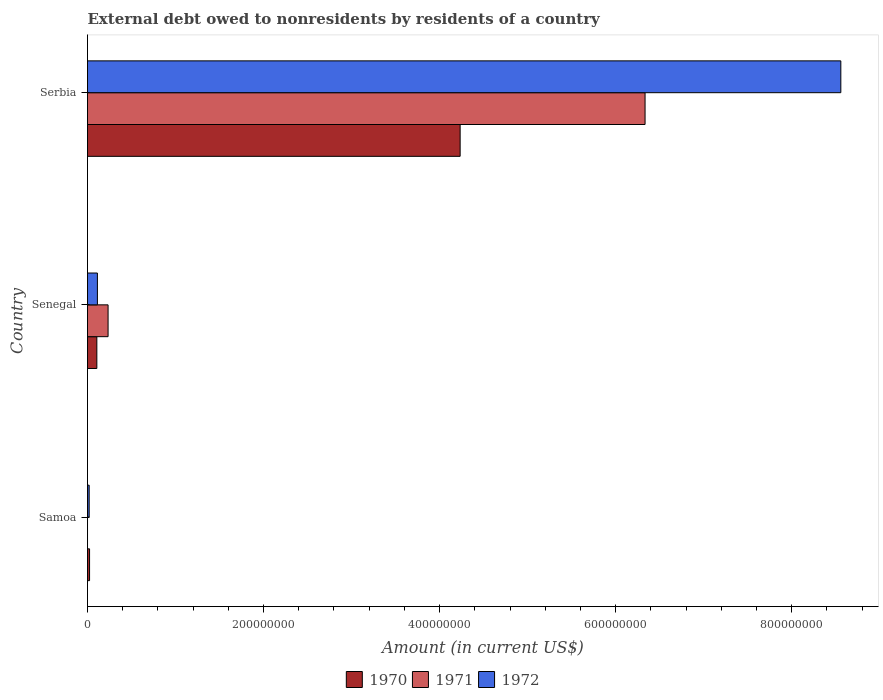How many different coloured bars are there?
Offer a terse response. 3. How many bars are there on the 2nd tick from the top?
Keep it short and to the point. 3. What is the label of the 2nd group of bars from the top?
Offer a very short reply. Senegal. What is the external debt owed by residents in 1972 in Senegal?
Your answer should be very brief. 1.12e+07. Across all countries, what is the maximum external debt owed by residents in 1970?
Provide a short and direct response. 4.23e+08. Across all countries, what is the minimum external debt owed by residents in 1972?
Your answer should be compact. 1.89e+06. In which country was the external debt owed by residents in 1970 maximum?
Your answer should be compact. Serbia. What is the total external debt owed by residents in 1972 in the graph?
Your response must be concise. 8.69e+08. What is the difference between the external debt owed by residents in 1972 in Samoa and that in Senegal?
Make the answer very short. -9.34e+06. What is the difference between the external debt owed by residents in 1970 in Serbia and the external debt owed by residents in 1971 in Senegal?
Your answer should be compact. 4.00e+08. What is the average external debt owed by residents in 1971 per country?
Give a very brief answer. 2.19e+08. What is the difference between the external debt owed by residents in 1970 and external debt owed by residents in 1972 in Serbia?
Provide a succinct answer. -4.32e+08. What is the ratio of the external debt owed by residents in 1970 in Samoa to that in Serbia?
Make the answer very short. 0.01. Is the external debt owed by residents in 1970 in Samoa less than that in Serbia?
Provide a succinct answer. Yes. Is the difference between the external debt owed by residents in 1970 in Samoa and Senegal greater than the difference between the external debt owed by residents in 1972 in Samoa and Senegal?
Offer a very short reply. Yes. What is the difference between the highest and the second highest external debt owed by residents in 1970?
Provide a succinct answer. 4.13e+08. What is the difference between the highest and the lowest external debt owed by residents in 1972?
Offer a terse response. 8.54e+08. What is the difference between two consecutive major ticks on the X-axis?
Your answer should be very brief. 2.00e+08. Are the values on the major ticks of X-axis written in scientific E-notation?
Make the answer very short. No. Does the graph contain grids?
Your answer should be compact. No. How many legend labels are there?
Offer a terse response. 3. What is the title of the graph?
Your answer should be very brief. External debt owed to nonresidents by residents of a country. What is the label or title of the Y-axis?
Ensure brevity in your answer.  Country. What is the Amount (in current US$) of 1970 in Samoa?
Offer a terse response. 2.32e+06. What is the Amount (in current US$) in 1972 in Samoa?
Provide a short and direct response. 1.89e+06. What is the Amount (in current US$) of 1970 in Senegal?
Provide a succinct answer. 1.06e+07. What is the Amount (in current US$) of 1971 in Senegal?
Ensure brevity in your answer.  2.34e+07. What is the Amount (in current US$) of 1972 in Senegal?
Your answer should be very brief. 1.12e+07. What is the Amount (in current US$) in 1970 in Serbia?
Your response must be concise. 4.23e+08. What is the Amount (in current US$) of 1971 in Serbia?
Make the answer very short. 6.33e+08. What is the Amount (in current US$) in 1972 in Serbia?
Your response must be concise. 8.56e+08. Across all countries, what is the maximum Amount (in current US$) in 1970?
Your answer should be very brief. 4.23e+08. Across all countries, what is the maximum Amount (in current US$) in 1971?
Give a very brief answer. 6.33e+08. Across all countries, what is the maximum Amount (in current US$) in 1972?
Your answer should be compact. 8.56e+08. Across all countries, what is the minimum Amount (in current US$) of 1970?
Your response must be concise. 2.32e+06. Across all countries, what is the minimum Amount (in current US$) of 1972?
Your answer should be compact. 1.89e+06. What is the total Amount (in current US$) of 1970 in the graph?
Provide a short and direct response. 4.36e+08. What is the total Amount (in current US$) of 1971 in the graph?
Keep it short and to the point. 6.57e+08. What is the total Amount (in current US$) in 1972 in the graph?
Offer a very short reply. 8.69e+08. What is the difference between the Amount (in current US$) of 1970 in Samoa and that in Senegal?
Offer a terse response. -8.28e+06. What is the difference between the Amount (in current US$) of 1972 in Samoa and that in Senegal?
Offer a terse response. -9.34e+06. What is the difference between the Amount (in current US$) in 1970 in Samoa and that in Serbia?
Provide a succinct answer. -4.21e+08. What is the difference between the Amount (in current US$) of 1972 in Samoa and that in Serbia?
Provide a succinct answer. -8.54e+08. What is the difference between the Amount (in current US$) in 1970 in Senegal and that in Serbia?
Give a very brief answer. -4.13e+08. What is the difference between the Amount (in current US$) of 1971 in Senegal and that in Serbia?
Keep it short and to the point. -6.10e+08. What is the difference between the Amount (in current US$) of 1972 in Senegal and that in Serbia?
Your response must be concise. -8.45e+08. What is the difference between the Amount (in current US$) of 1970 in Samoa and the Amount (in current US$) of 1971 in Senegal?
Offer a terse response. -2.10e+07. What is the difference between the Amount (in current US$) in 1970 in Samoa and the Amount (in current US$) in 1972 in Senegal?
Your answer should be very brief. -8.91e+06. What is the difference between the Amount (in current US$) in 1970 in Samoa and the Amount (in current US$) in 1971 in Serbia?
Your response must be concise. -6.31e+08. What is the difference between the Amount (in current US$) of 1970 in Samoa and the Amount (in current US$) of 1972 in Serbia?
Ensure brevity in your answer.  -8.54e+08. What is the difference between the Amount (in current US$) in 1970 in Senegal and the Amount (in current US$) in 1971 in Serbia?
Provide a succinct answer. -6.23e+08. What is the difference between the Amount (in current US$) in 1970 in Senegal and the Amount (in current US$) in 1972 in Serbia?
Give a very brief answer. -8.45e+08. What is the difference between the Amount (in current US$) in 1971 in Senegal and the Amount (in current US$) in 1972 in Serbia?
Offer a terse response. -8.32e+08. What is the average Amount (in current US$) of 1970 per country?
Provide a succinct answer. 1.45e+08. What is the average Amount (in current US$) of 1971 per country?
Keep it short and to the point. 2.19e+08. What is the average Amount (in current US$) in 1972 per country?
Keep it short and to the point. 2.90e+08. What is the difference between the Amount (in current US$) in 1970 and Amount (in current US$) in 1972 in Samoa?
Make the answer very short. 4.36e+05. What is the difference between the Amount (in current US$) of 1970 and Amount (in current US$) of 1971 in Senegal?
Offer a terse response. -1.28e+07. What is the difference between the Amount (in current US$) of 1970 and Amount (in current US$) of 1972 in Senegal?
Provide a succinct answer. -6.30e+05. What is the difference between the Amount (in current US$) of 1971 and Amount (in current US$) of 1972 in Senegal?
Give a very brief answer. 1.21e+07. What is the difference between the Amount (in current US$) in 1970 and Amount (in current US$) in 1971 in Serbia?
Ensure brevity in your answer.  -2.10e+08. What is the difference between the Amount (in current US$) of 1970 and Amount (in current US$) of 1972 in Serbia?
Your answer should be very brief. -4.32e+08. What is the difference between the Amount (in current US$) in 1971 and Amount (in current US$) in 1972 in Serbia?
Provide a succinct answer. -2.22e+08. What is the ratio of the Amount (in current US$) in 1970 in Samoa to that in Senegal?
Provide a short and direct response. 0.22. What is the ratio of the Amount (in current US$) of 1972 in Samoa to that in Senegal?
Your answer should be very brief. 0.17. What is the ratio of the Amount (in current US$) in 1970 in Samoa to that in Serbia?
Your answer should be very brief. 0.01. What is the ratio of the Amount (in current US$) of 1972 in Samoa to that in Serbia?
Make the answer very short. 0. What is the ratio of the Amount (in current US$) of 1970 in Senegal to that in Serbia?
Your answer should be compact. 0.03. What is the ratio of the Amount (in current US$) in 1971 in Senegal to that in Serbia?
Offer a very short reply. 0.04. What is the ratio of the Amount (in current US$) of 1972 in Senegal to that in Serbia?
Your answer should be very brief. 0.01. What is the difference between the highest and the second highest Amount (in current US$) in 1970?
Offer a terse response. 4.13e+08. What is the difference between the highest and the second highest Amount (in current US$) in 1972?
Your answer should be compact. 8.45e+08. What is the difference between the highest and the lowest Amount (in current US$) in 1970?
Provide a succinct answer. 4.21e+08. What is the difference between the highest and the lowest Amount (in current US$) of 1971?
Give a very brief answer. 6.33e+08. What is the difference between the highest and the lowest Amount (in current US$) in 1972?
Your answer should be compact. 8.54e+08. 